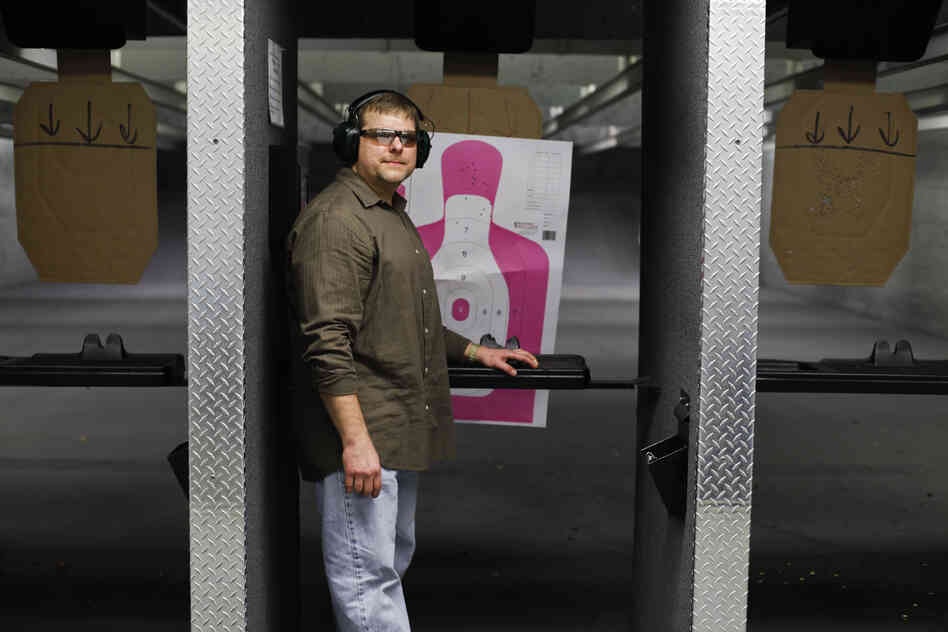What features of the shooting range can be identified that cater to both novice and experienced shooters? The shooting range in the image has several identifiable features designed to cater to both novice and experienced shooters. The human silhouette target with its colored zones offers a clear visual aid for shooters of all skill levels; novice shooters can receive immediate feedback on their accuracy, while experienced shooters can aim for smaller, more challenging zones to refine their precision.

Additionally, the shooting booth provides a flat horizontal surface for resting firearms and other equipment, aiding those who need to set up or adjust their gear. The presence of protective ear muffs and glasses on the shooter indicates that the range enforces strict safety protocols, crucial for novices who are still learning safety practices.

Another target with black symbols might be used for more advanced training, allowing experienced shooters to engage in exercises like shooting at smaller targets or following a specific sequence. Overall, the range's layout, with its clear separation between booths and targets, ensures a controlled environment that accommodates shooters’ varying skill levels, allowing each to practice at their preferred pace and comfort level. 